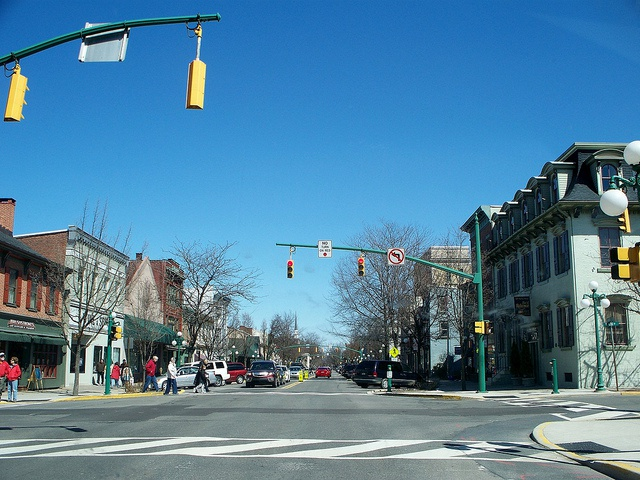Describe the objects in this image and their specific colors. I can see car in darkblue, black, gray, teal, and navy tones, traffic light in darkblue, gold, khaki, and gray tones, traffic light in darkblue, khaki, and maroon tones, car in darkblue, black, gray, navy, and darkgray tones, and people in darkblue, black, darkgray, lightgray, and gray tones in this image. 